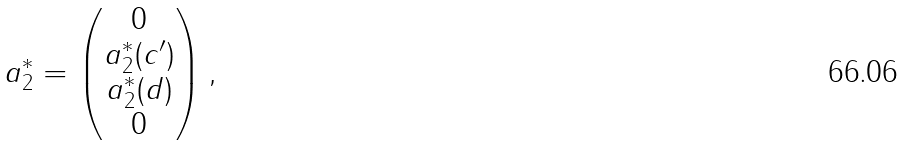<formula> <loc_0><loc_0><loc_500><loc_500>a _ { 2 } ^ { \ast } = \left ( \begin{matrix} 0 \\ a _ { 2 } ^ { \ast } ( c ^ { \prime } ) \\ a _ { 2 } ^ { \ast } ( d ) \\ 0 \end{matrix} \right ) ,</formula> 